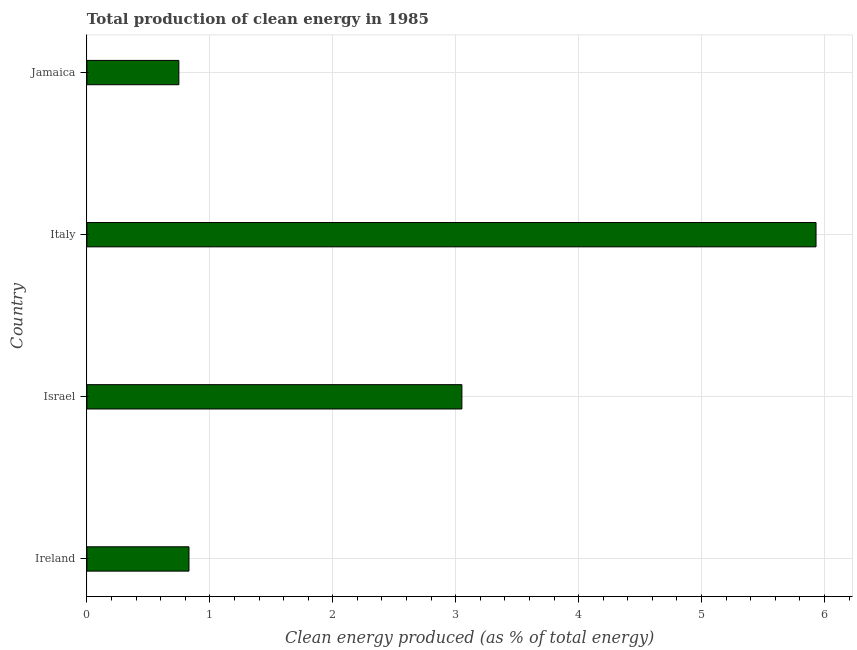Does the graph contain grids?
Your answer should be very brief. Yes. What is the title of the graph?
Keep it short and to the point. Total production of clean energy in 1985. What is the label or title of the X-axis?
Your response must be concise. Clean energy produced (as % of total energy). What is the label or title of the Y-axis?
Keep it short and to the point. Country. What is the production of clean energy in Israel?
Your response must be concise. 3.05. Across all countries, what is the maximum production of clean energy?
Keep it short and to the point. 5.93. Across all countries, what is the minimum production of clean energy?
Your answer should be very brief. 0.75. In which country was the production of clean energy maximum?
Make the answer very short. Italy. In which country was the production of clean energy minimum?
Ensure brevity in your answer.  Jamaica. What is the sum of the production of clean energy?
Your answer should be very brief. 10.56. What is the difference between the production of clean energy in Israel and Italy?
Ensure brevity in your answer.  -2.88. What is the average production of clean energy per country?
Ensure brevity in your answer.  2.64. What is the median production of clean energy?
Ensure brevity in your answer.  1.94. In how many countries, is the production of clean energy greater than 1 %?
Offer a very short reply. 2. What is the ratio of the production of clean energy in Israel to that in Italy?
Provide a succinct answer. 0.51. Is the difference between the production of clean energy in Italy and Jamaica greater than the difference between any two countries?
Make the answer very short. Yes. What is the difference between the highest and the second highest production of clean energy?
Offer a very short reply. 2.88. What is the difference between the highest and the lowest production of clean energy?
Offer a terse response. 5.18. In how many countries, is the production of clean energy greater than the average production of clean energy taken over all countries?
Make the answer very short. 2. How many bars are there?
Ensure brevity in your answer.  4. Are all the bars in the graph horizontal?
Give a very brief answer. Yes. How many countries are there in the graph?
Your answer should be compact. 4. What is the difference between two consecutive major ticks on the X-axis?
Ensure brevity in your answer.  1. Are the values on the major ticks of X-axis written in scientific E-notation?
Provide a short and direct response. No. What is the Clean energy produced (as % of total energy) of Ireland?
Offer a very short reply. 0.83. What is the Clean energy produced (as % of total energy) in Israel?
Give a very brief answer. 3.05. What is the Clean energy produced (as % of total energy) in Italy?
Provide a short and direct response. 5.93. What is the Clean energy produced (as % of total energy) of Jamaica?
Ensure brevity in your answer.  0.75. What is the difference between the Clean energy produced (as % of total energy) in Ireland and Israel?
Ensure brevity in your answer.  -2.22. What is the difference between the Clean energy produced (as % of total energy) in Ireland and Italy?
Offer a very short reply. -5.1. What is the difference between the Clean energy produced (as % of total energy) in Ireland and Jamaica?
Make the answer very short. 0.08. What is the difference between the Clean energy produced (as % of total energy) in Israel and Italy?
Offer a terse response. -2.88. What is the difference between the Clean energy produced (as % of total energy) in Israel and Jamaica?
Ensure brevity in your answer.  2.3. What is the difference between the Clean energy produced (as % of total energy) in Italy and Jamaica?
Give a very brief answer. 5.18. What is the ratio of the Clean energy produced (as % of total energy) in Ireland to that in Israel?
Your answer should be compact. 0.27. What is the ratio of the Clean energy produced (as % of total energy) in Ireland to that in Italy?
Ensure brevity in your answer.  0.14. What is the ratio of the Clean energy produced (as % of total energy) in Ireland to that in Jamaica?
Provide a short and direct response. 1.11. What is the ratio of the Clean energy produced (as % of total energy) in Israel to that in Italy?
Keep it short and to the point. 0.51. What is the ratio of the Clean energy produced (as % of total energy) in Israel to that in Jamaica?
Your answer should be very brief. 4.08. What is the ratio of the Clean energy produced (as % of total energy) in Italy to that in Jamaica?
Provide a short and direct response. 7.93. 